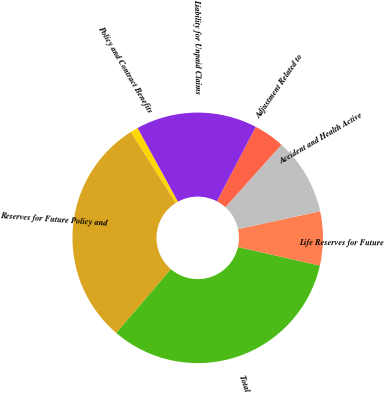Convert chart. <chart><loc_0><loc_0><loc_500><loc_500><pie_chart><fcel>Policy and Contract Benefits<fcel>Reserves for Future Policy and<fcel>Total<fcel>Life Reserves for Future<fcel>Accident and Health Active<fcel>Adjustment Related to<fcel>Liability for Unpaid Claims<nl><fcel>1.01%<fcel>29.75%<fcel>32.72%<fcel>6.96%<fcel>9.94%<fcel>3.99%<fcel>15.63%<nl></chart> 